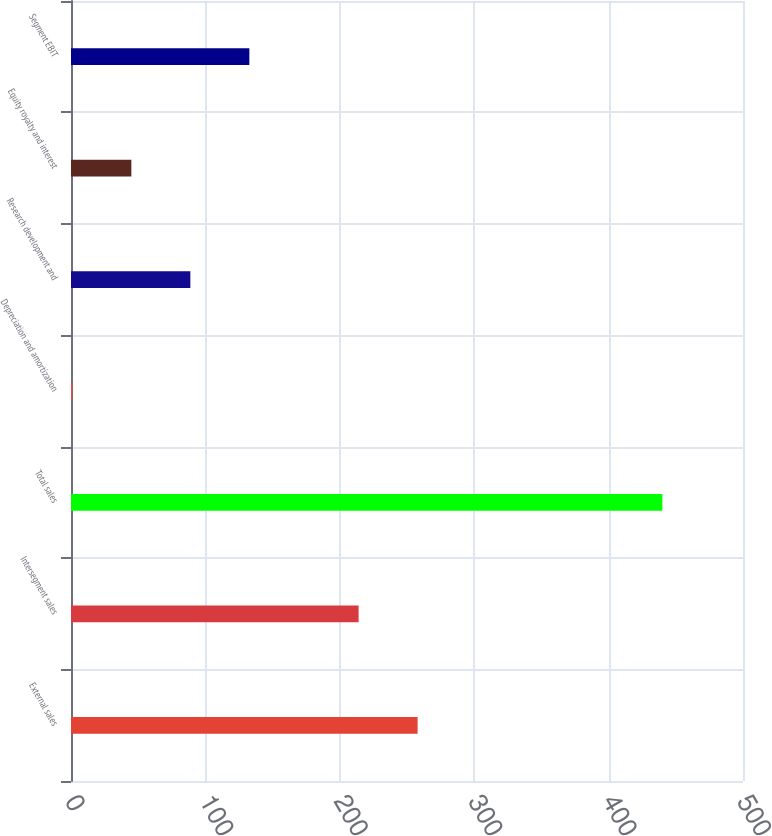Convert chart. <chart><loc_0><loc_0><loc_500><loc_500><bar_chart><fcel>External sales<fcel>Intersegment sales<fcel>Total sales<fcel>Depreciation and amortization<fcel>Research development and<fcel>Equity royalty and interest<fcel>Segment EBIT<nl><fcel>257.9<fcel>214<fcel>440<fcel>1<fcel>88.8<fcel>44.9<fcel>132.7<nl></chart> 